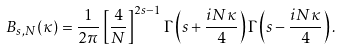Convert formula to latex. <formula><loc_0><loc_0><loc_500><loc_500>B _ { s , N } ( \kappa ) = \frac { 1 } { 2 \pi } \left [ \frac { 4 } { N } \right ] ^ { 2 s - 1 } \Gamma \left ( s + \frac { i N \kappa } { 4 } \right ) \Gamma \left ( s - \frac { i N \kappa } { 4 } \right ) .</formula> 